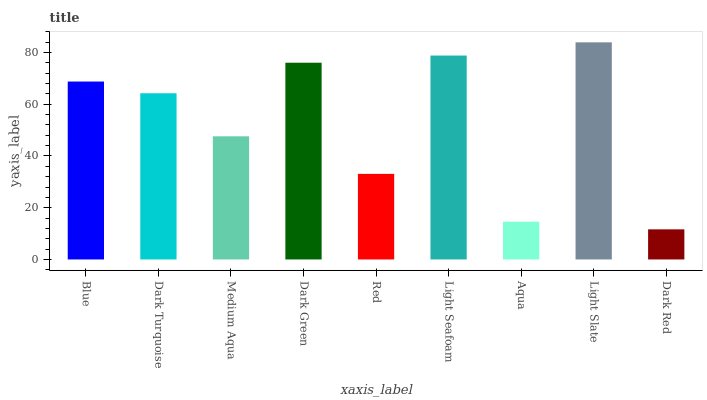Is Dark Red the minimum?
Answer yes or no. Yes. Is Light Slate the maximum?
Answer yes or no. Yes. Is Dark Turquoise the minimum?
Answer yes or no. No. Is Dark Turquoise the maximum?
Answer yes or no. No. Is Blue greater than Dark Turquoise?
Answer yes or no. Yes. Is Dark Turquoise less than Blue?
Answer yes or no. Yes. Is Dark Turquoise greater than Blue?
Answer yes or no. No. Is Blue less than Dark Turquoise?
Answer yes or no. No. Is Dark Turquoise the high median?
Answer yes or no. Yes. Is Dark Turquoise the low median?
Answer yes or no. Yes. Is Light Slate the high median?
Answer yes or no. No. Is Aqua the low median?
Answer yes or no. No. 